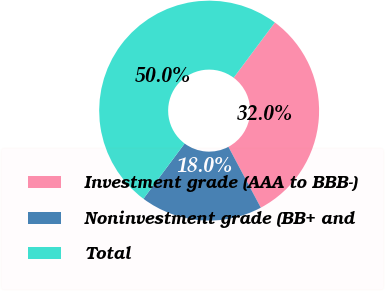Convert chart to OTSL. <chart><loc_0><loc_0><loc_500><loc_500><pie_chart><fcel>Investment grade (AAA to BBB-)<fcel>Noninvestment grade (BB+ and<fcel>Total<nl><fcel>32.02%<fcel>17.98%<fcel>50.0%<nl></chart> 